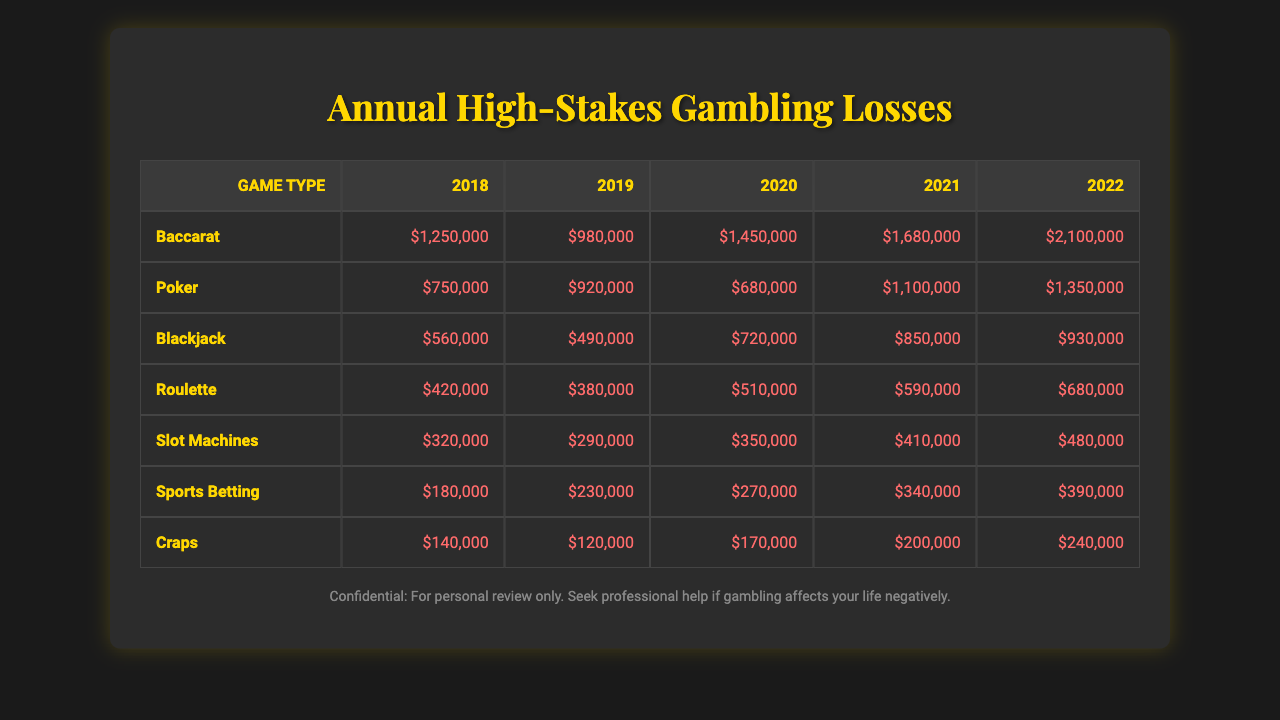What was the total loss in 2022 for all game types combined? To find the total loss in 2022, we need to sum the losses from each game type for that year. The losses in 2022 are: Baccarat ($2,100,000), Poker ($1,350,000), Blackjack ($930,000), Roulette ($680,000), Slot Machines ($480,000), Sports Betting ($390,000), and Craps ($240,000). Adding them gives: 2,100,000 + 1,350,000 + 930,000 + 680,000 + 480,000 + 390,000 + 240,000 = $5,120,000.
Answer: $5,120,000 Which game type had the highest loss in 2021? By examining the losses for each game type in 2021, Baccarat showed the highest loss at $1,680,000.
Answer: Baccarat Did the losses from Poker increase every year from 2018 to 2022? We need to check the losses of Poker for each year: in 2018 it was $750,000, in 2019 it was $920,000, in 2020 it was $680,000 (which decreased), then in 2021 it was $1,100,000, and in 2022 it was $1,350,000. Since there was a decrease in 2020, the losses did not increase every year.
Answer: No What was the percentage increase in losses from Blackjack between 2018 and 2022? The loss for Blackjack in 2018 was $560,000, and in 2022 it was $930,000. The increase is $930,000 - $560,000 = $370,000. To find the percentage increase, we calculate ($370,000 / $560,000) * 100% = 66.07%.
Answer: 66.07% What was the lowest losing game type in 2020? Looking at the losses for 2020, the amounts are: Baccarat ($1,450,000), Poker ($680,000), Blackjack ($720,000), Roulette ($510,000), Slot Machines ($350,000), Sports Betting ($270,000), and Craps ($170,000). The lowest loss among these is from Craps at $170,000.
Answer: Craps Which game type had the most consistent losses over the years without significant spikes? To determine consistency, we look at the losses for each game type over the years. Slot Machines show gradual increases from $320,000 in 2018 to $480,000 in 2022, with no dramatic spikes compared to the fluctuations in other games.
Answer: Slot Machines What were the total losses for Roulette from 2018 to 2022? The losses for Roulette over the years are as follows: 2018 ($420,000), 2019 ($380,000), 2020 ($510,000), 2021 ($590,000), and 2022 ($680,000). Summing these amounts gives $420,000 + $380,000 + $510,000 + $590,000 + $680,000 = $2,580,000.
Answer: $2,580,000 Was there a year where Sports Betting had losses greater than $300,000? Checking the losses for Sports Betting: in 2018 it was $180,000, 2019 it was $230,000, 2020 it was $270,000, 2021 it was $340,000, and in 2022 it was $390,000. Notably, only in 2021 and 2022 were the losses greater than $300,000.
Answer: Yes What was the average loss for all game types in 2019? To calculate the average loss in 2019, we sum the losses: Baccarat ($920,000), Poker ($1,100,000), Blackjack ($490,000), Roulette ($380,000), Slot Machines ($290,000), Sports Betting ($230,000), and Craps ($120,000), leading to a total of $3,930,000. Dividing by the number of game types (7) yields an average of $3,930,000 / 7 = $561,428.57.
Answer: $561,428.57 How much more did Baccarat lose in 2022 compared to Craps? The loss for Baccarat in 2022 was $2,100,000 and for Craps was $240,000. The difference is $2,100,000 - $240,000 = $1,860,000.
Answer: $1,860,000 